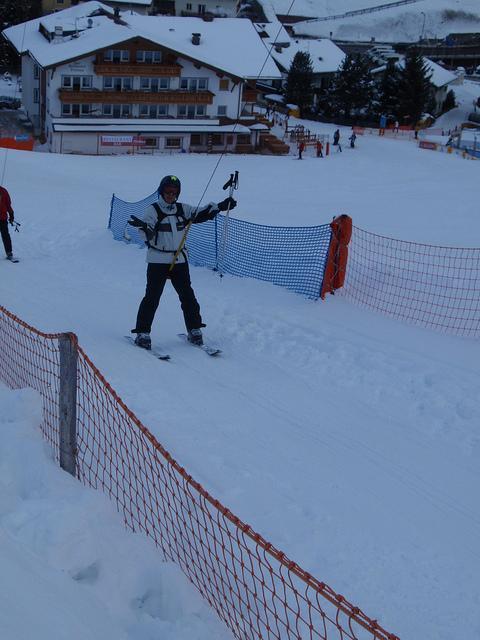What's the name of the large white building in the background?
From the following four choices, select the correct answer to address the question.
Options: Hotel, lodge, terminal, casino. Lodge. 